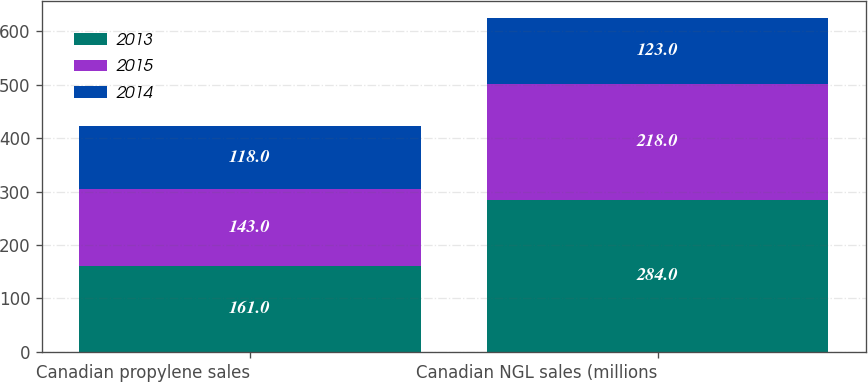Convert chart to OTSL. <chart><loc_0><loc_0><loc_500><loc_500><stacked_bar_chart><ecel><fcel>Canadian propylene sales<fcel>Canadian NGL sales (millions<nl><fcel>2013<fcel>161<fcel>284<nl><fcel>2015<fcel>143<fcel>218<nl><fcel>2014<fcel>118<fcel>123<nl></chart> 